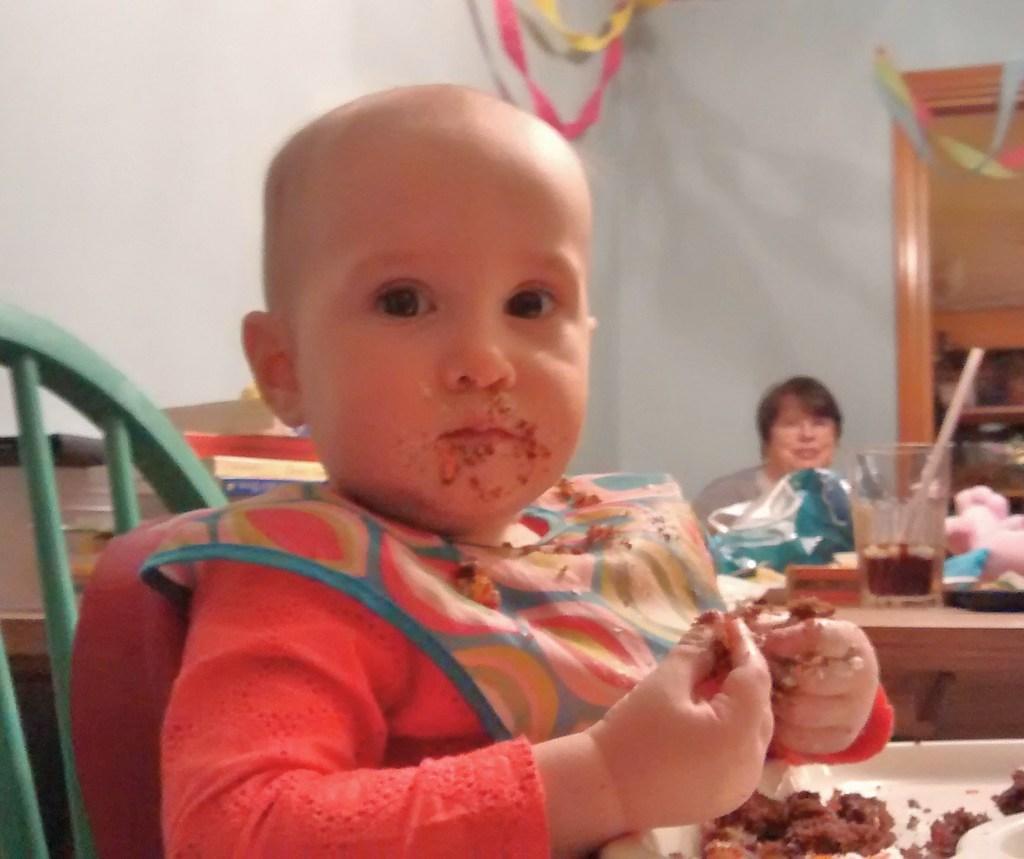In one or two sentences, can you explain what this image depicts? In the picture we can see a kid wearing orange color dress sitting on a chair and having some food and in the background of the picture there are some books, glasses, some other objects on the table and there is a woman sitting and there is a wall. 